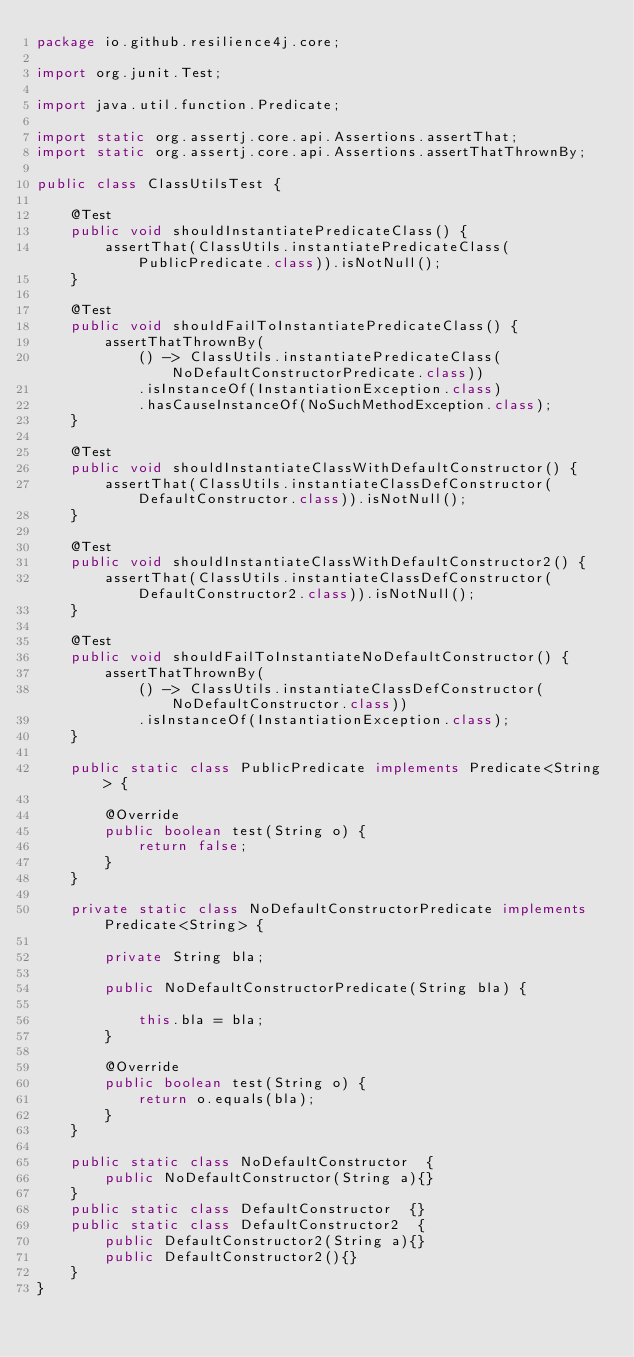<code> <loc_0><loc_0><loc_500><loc_500><_Java_>package io.github.resilience4j.core;

import org.junit.Test;

import java.util.function.Predicate;

import static org.assertj.core.api.Assertions.assertThat;
import static org.assertj.core.api.Assertions.assertThatThrownBy;

public class ClassUtilsTest {

    @Test
    public void shouldInstantiatePredicateClass() {
        assertThat(ClassUtils.instantiatePredicateClass(PublicPredicate.class)).isNotNull();
    }

    @Test
    public void shouldFailToInstantiatePredicateClass() {
        assertThatThrownBy(
            () -> ClassUtils.instantiatePredicateClass(NoDefaultConstructorPredicate.class))
            .isInstanceOf(InstantiationException.class)
            .hasCauseInstanceOf(NoSuchMethodException.class);
    }

    @Test
    public void shouldInstantiateClassWithDefaultConstructor() {
        assertThat(ClassUtils.instantiateClassDefConstructor(DefaultConstructor.class)).isNotNull();
    }

    @Test
    public void shouldInstantiateClassWithDefaultConstructor2() {
        assertThat(ClassUtils.instantiateClassDefConstructor(DefaultConstructor2.class)).isNotNull();
    }

    @Test
    public void shouldFailToInstantiateNoDefaultConstructor() {
        assertThatThrownBy(
            () -> ClassUtils.instantiateClassDefConstructor(NoDefaultConstructor.class))
            .isInstanceOf(InstantiationException.class);
    }

    public static class PublicPredicate implements Predicate<String> {

        @Override
        public boolean test(String o) {
            return false;
        }
    }

    private static class NoDefaultConstructorPredicate implements Predicate<String> {

        private String bla;

        public NoDefaultConstructorPredicate(String bla) {

            this.bla = bla;
        }

        @Override
        public boolean test(String o) {
            return o.equals(bla);
        }
    }

    public static class NoDefaultConstructor  {
        public NoDefaultConstructor(String a){}
    }
    public static class DefaultConstructor  {}
    public static class DefaultConstructor2  {
        public DefaultConstructor2(String a){}
        public DefaultConstructor2(){}
    }
}
</code> 